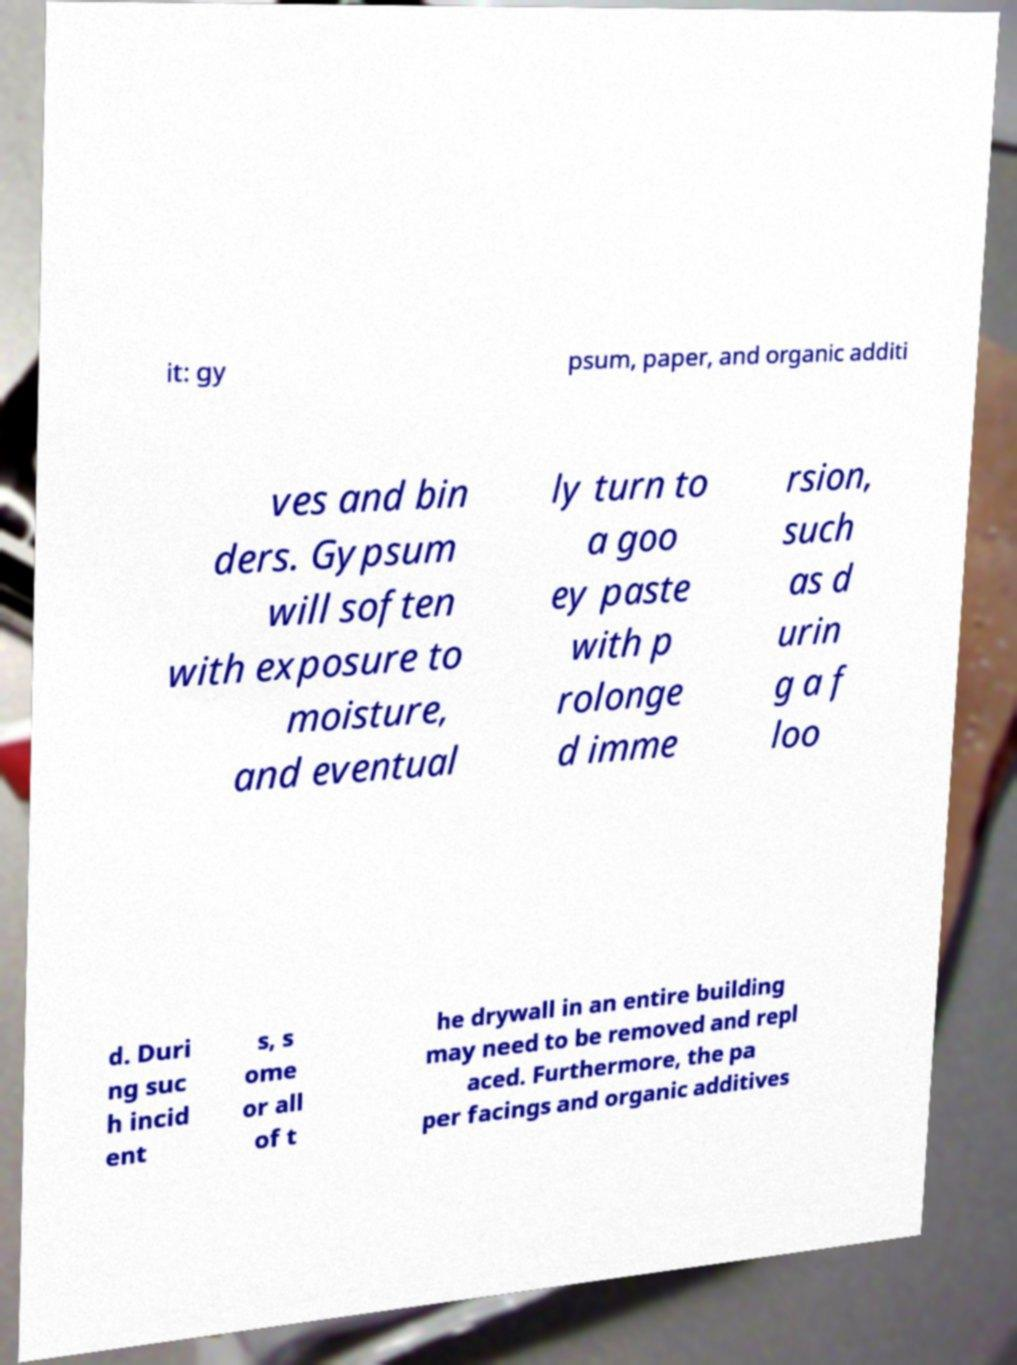Could you assist in decoding the text presented in this image and type it out clearly? it: gy psum, paper, and organic additi ves and bin ders. Gypsum will soften with exposure to moisture, and eventual ly turn to a goo ey paste with p rolonge d imme rsion, such as d urin g a f loo d. Duri ng suc h incid ent s, s ome or all of t he drywall in an entire building may need to be removed and repl aced. Furthermore, the pa per facings and organic additives 